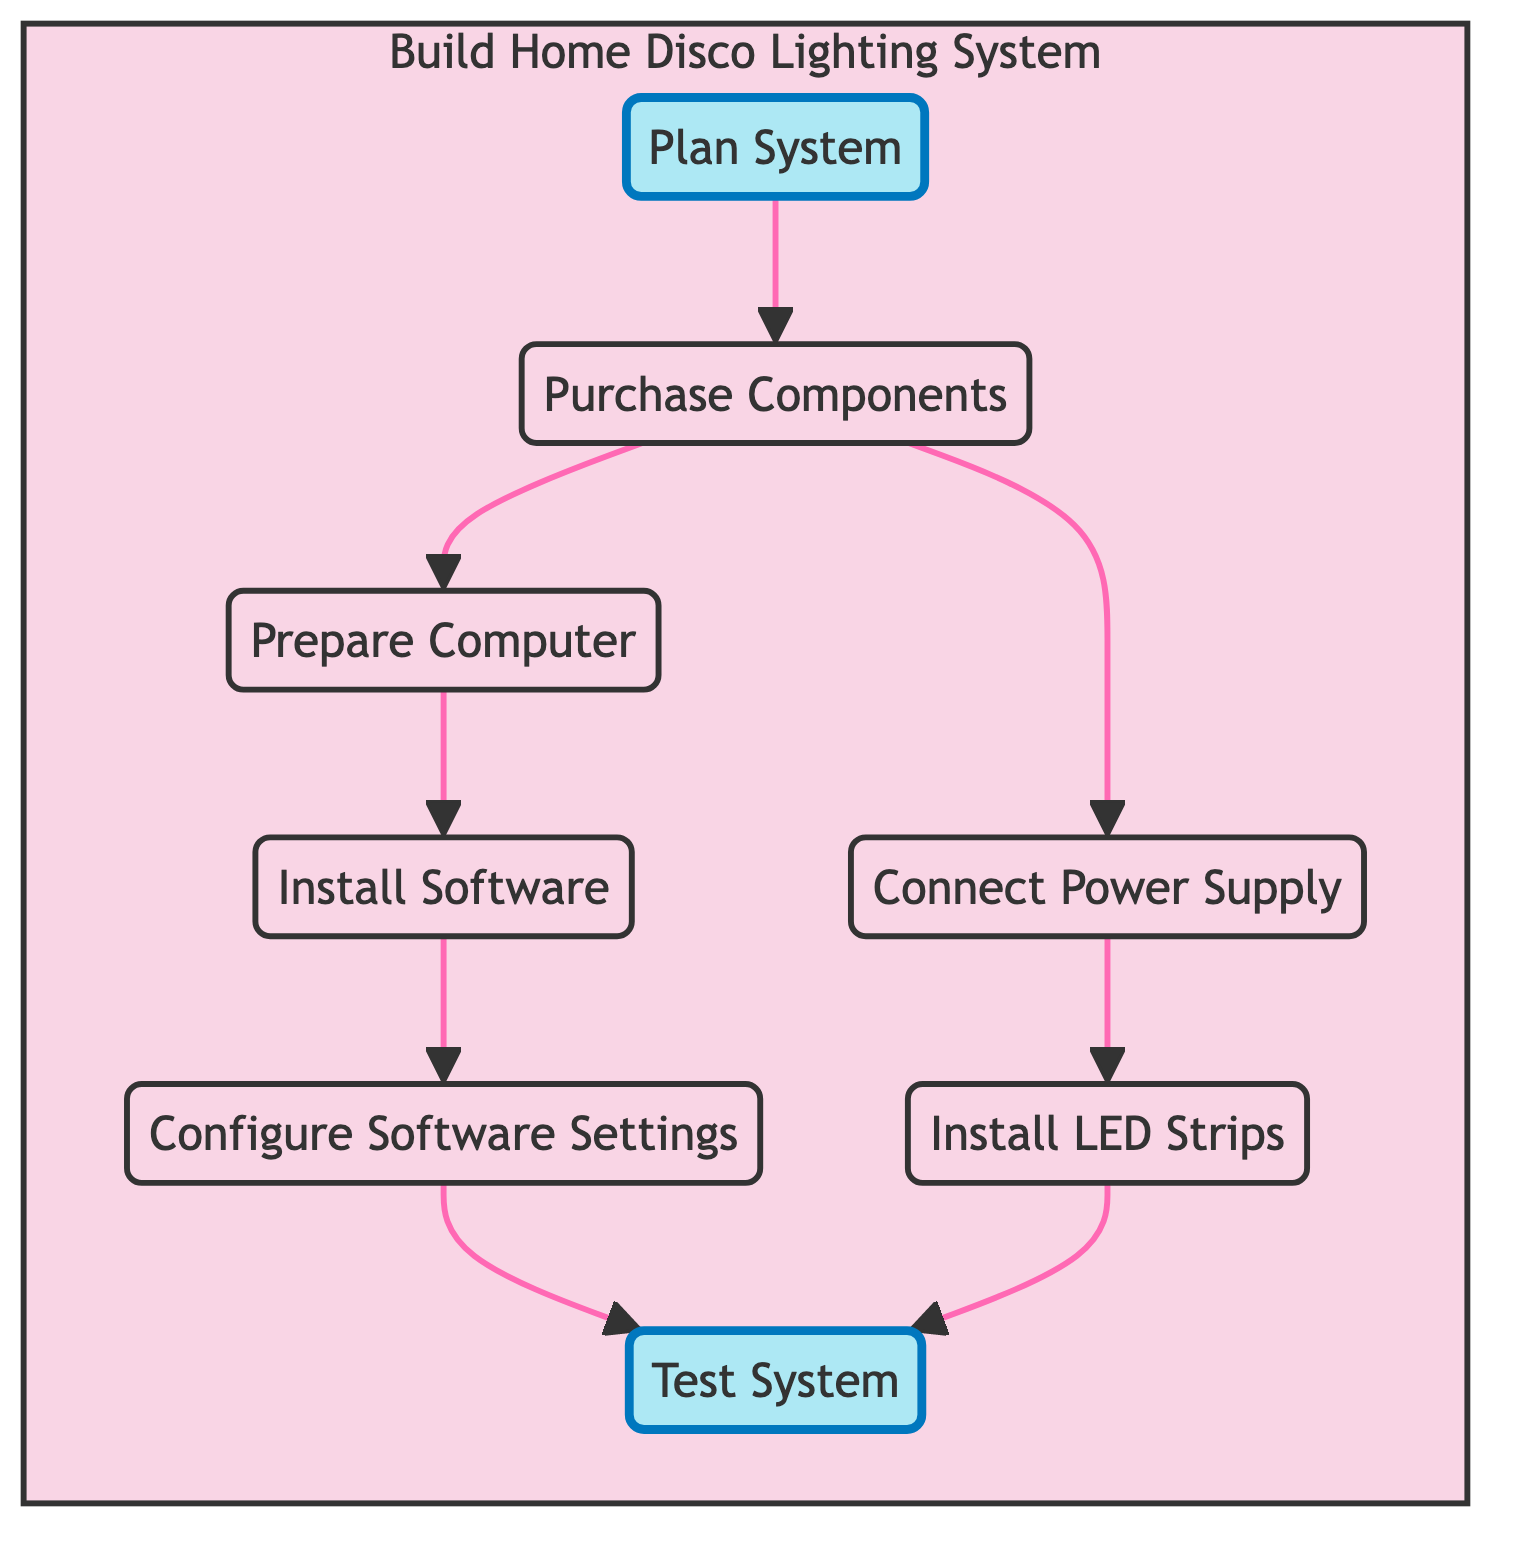What's the first step in the process? The first step in the flowchart is "Plan System," which is the initial phase of the "Build Home Disco Lighting System." It does not have any dependencies.
Answer: Plan System How many nodes are in the diagram? The diagram contains eight nodes, each representing a different step in building the home disco lighting system.
Answer: Eight What step follows "Install Software"? The step that follows "Install Software" is "Configure Software Settings." This is the next step in the process after installation.
Answer: Configure Software Settings What are the dependencies for "Test System"? "Test System" depends on two steps: "Configure Software Settings" and "Install LED Strips." Both must be completed before testing can occur.
Answer: Configure Software Settings, Install LED Strips Which step requires the preparation of the computer? The step that requires preparation of the computer is "Prepare Computer." It requires ensuring that the computer has necessary ports and meets software specifications.
Answer: Prepare Computer Which steps are highlighted in the diagram? The highlighted steps in the diagram are "Plan System" and "Test System." Highlighting these steps emphasizes their importance in the process.
Answer: Plan System, Test System What is the last step in the process? The last step in the process is "Test System." It evaluates the overall functionality and synchronization of the lighting system with music.
Answer: Test System What do you need to do before "Install LED Strips"? Before "Install LED Strips," you need to "Connect Power Supply." This is necessary to ensure power to the LED strips.
Answer: Connect Power Supply How many dependencies does "Configure Software Settings" have? "Configure Software Settings" has one dependency, which is "Install Software." This step must be completed prior to configuration.
Answer: One 